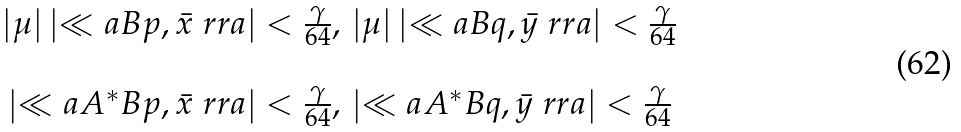<formula> <loc_0><loc_0><loc_500><loc_500>\begin{array} { c } | \mu | \left | \ll a B p , \bar { x } \ r r a \right | < \frac { \gamma } { 6 4 } , \, | \mu | \left | \ll a B q , \bar { y } \ r r a \right | < \frac { \gamma } { 6 4 } \\ \\ \left | \ll a A ^ { * } B p , \bar { x } \ r r a \right | < \frac { \gamma } { 6 4 } , \, \left | \ll a A ^ { * } B q , \bar { y } \ r r a \right | < \frac { \gamma } { 6 4 } \end{array}</formula> 